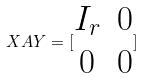Convert formula to latex. <formula><loc_0><loc_0><loc_500><loc_500>X A Y = [ \begin{matrix} I _ { r } & 0 \\ 0 & 0 \\ \end{matrix} ]</formula> 